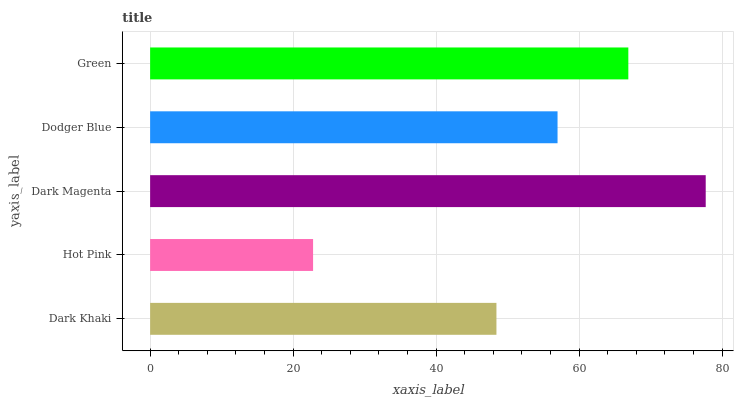Is Hot Pink the minimum?
Answer yes or no. Yes. Is Dark Magenta the maximum?
Answer yes or no. Yes. Is Dark Magenta the minimum?
Answer yes or no. No. Is Hot Pink the maximum?
Answer yes or no. No. Is Dark Magenta greater than Hot Pink?
Answer yes or no. Yes. Is Hot Pink less than Dark Magenta?
Answer yes or no. Yes. Is Hot Pink greater than Dark Magenta?
Answer yes or no. No. Is Dark Magenta less than Hot Pink?
Answer yes or no. No. Is Dodger Blue the high median?
Answer yes or no. Yes. Is Dodger Blue the low median?
Answer yes or no. Yes. Is Dark Magenta the high median?
Answer yes or no. No. Is Dark Khaki the low median?
Answer yes or no. No. 